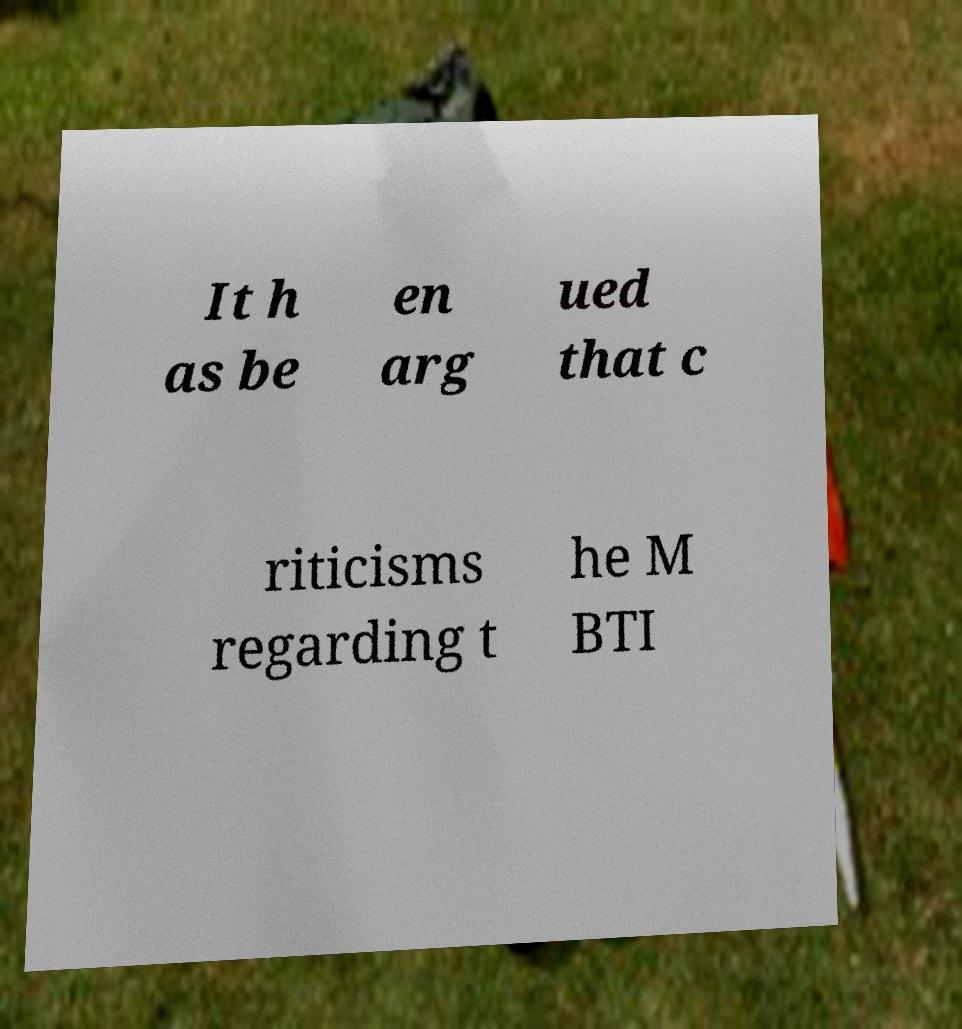Could you assist in decoding the text presented in this image and type it out clearly? It h as be en arg ued that c riticisms regarding t he M BTI 